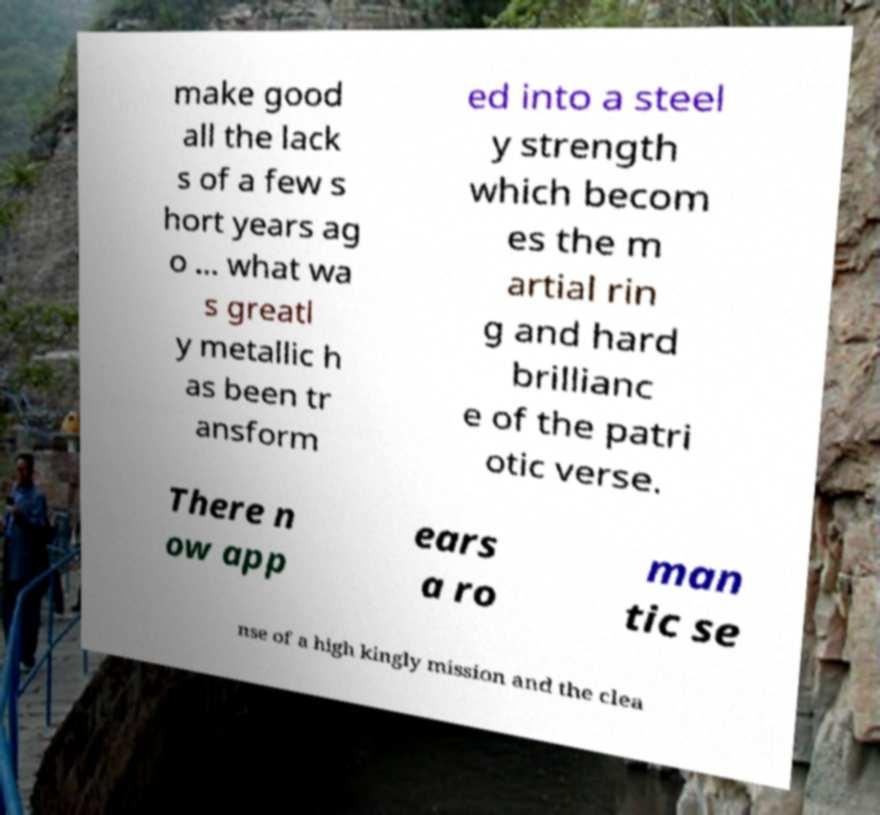Please read and relay the text visible in this image. What does it say? make good all the lack s of a few s hort years ag o ... what wa s greatl y metallic h as been tr ansform ed into a steel y strength which becom es the m artial rin g and hard brillianc e of the patri otic verse. There n ow app ears a ro man tic se nse of a high kingly mission and the clea 